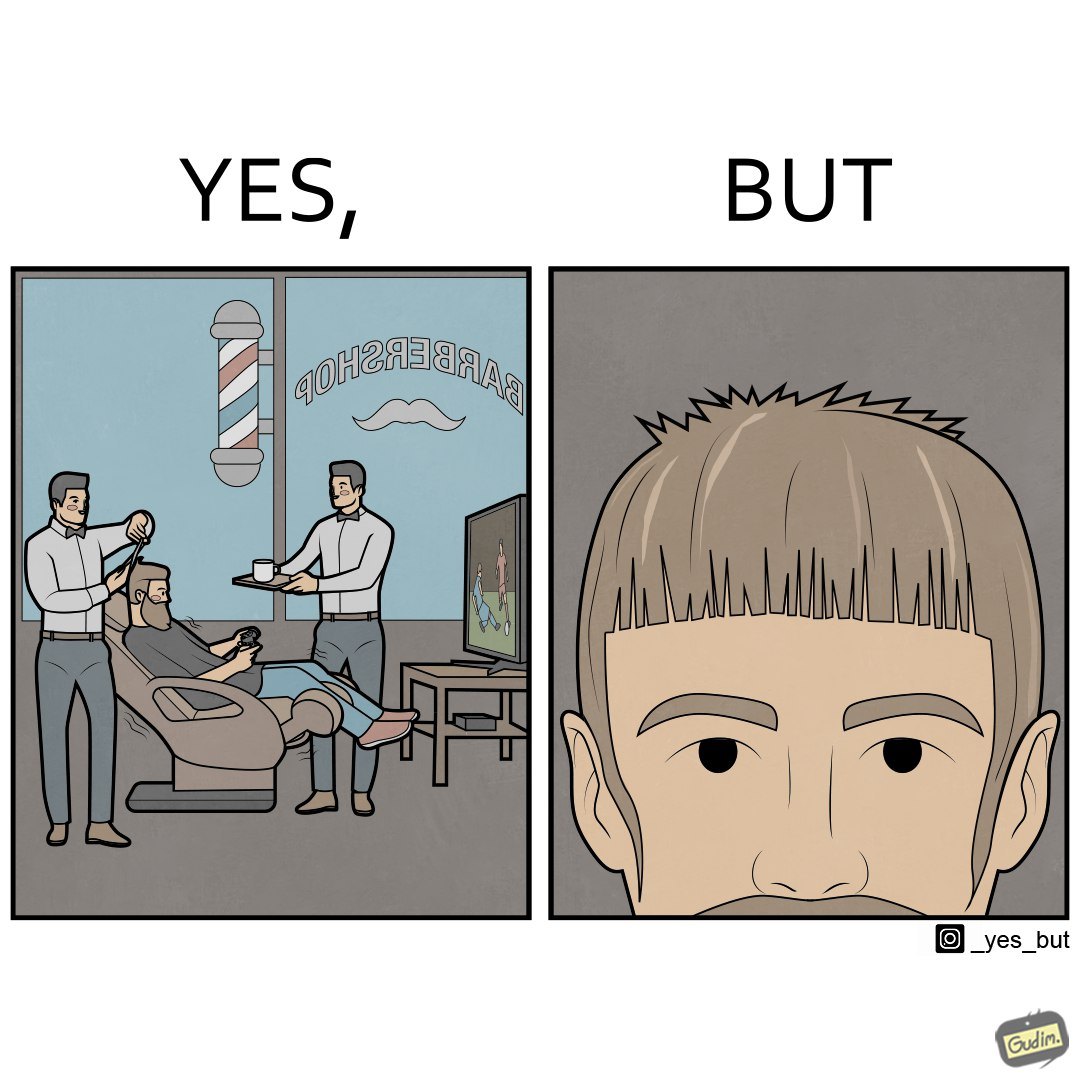Describe the content of this image. The image is ironic, because the sole purpose of the person was to get a hair cut but he became so much engrossed in the game that the barber wasn't able to cut his hairs properly. and even the saloon is providing so many facilities but they don't have a good hairdresser 